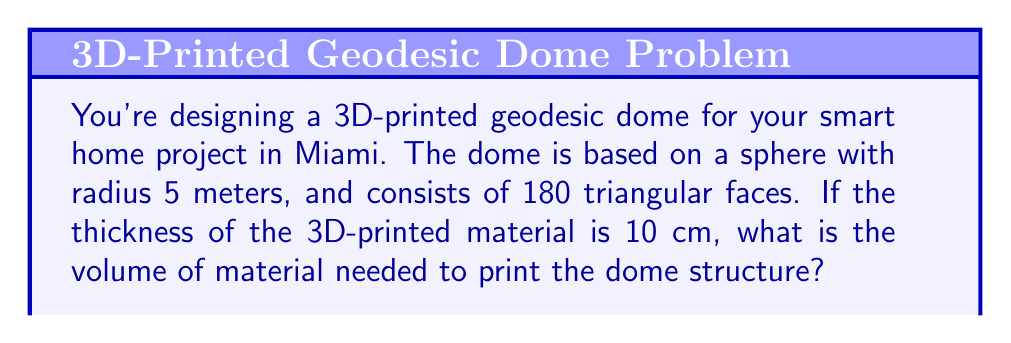What is the answer to this math problem? Let's approach this step-by-step:

1) First, we need to calculate the surface area of the sphere:
   $$A = 4\pi r^2 = 4\pi (5\text{ m})^2 = 314.16\text{ m}^2$$

2) The geodesic dome doesn't cover the entire sphere. Typically, it covers about 5/6 of the sphere's surface area:
   $$A_{\text{dome}} = \frac{5}{6} \times 314.16\text{ m}^2 = 261.80\text{ m}^2$$

3) Now, we need to calculate the volume of the 3D-printed material. It's like a shell around the dome surface. The volume will be the surface area multiplied by the thickness:
   $$V = A_{\text{dome}} \times \text{thickness}$$
   $$V = 261.80\text{ m}^2 \times 0.10\text{ m} = 26.18\text{ m}^3$$

4) However, this calculation assumes a smooth surface. A geodesic dome consists of flat triangular faces. This will slightly reduce the volume. Let's assume it reduces the volume by about 5%:
   $$V_{\text{final}} = 26.18\text{ m}^3 \times 0.95 = 24.87\text{ m}^3$$

5) Converting to a more practical unit for 3D printing:
   $$24.87\text{ m}^3 = 24,870,000\text{ cm}^3$$
Answer: 24,870,000 cm³ 